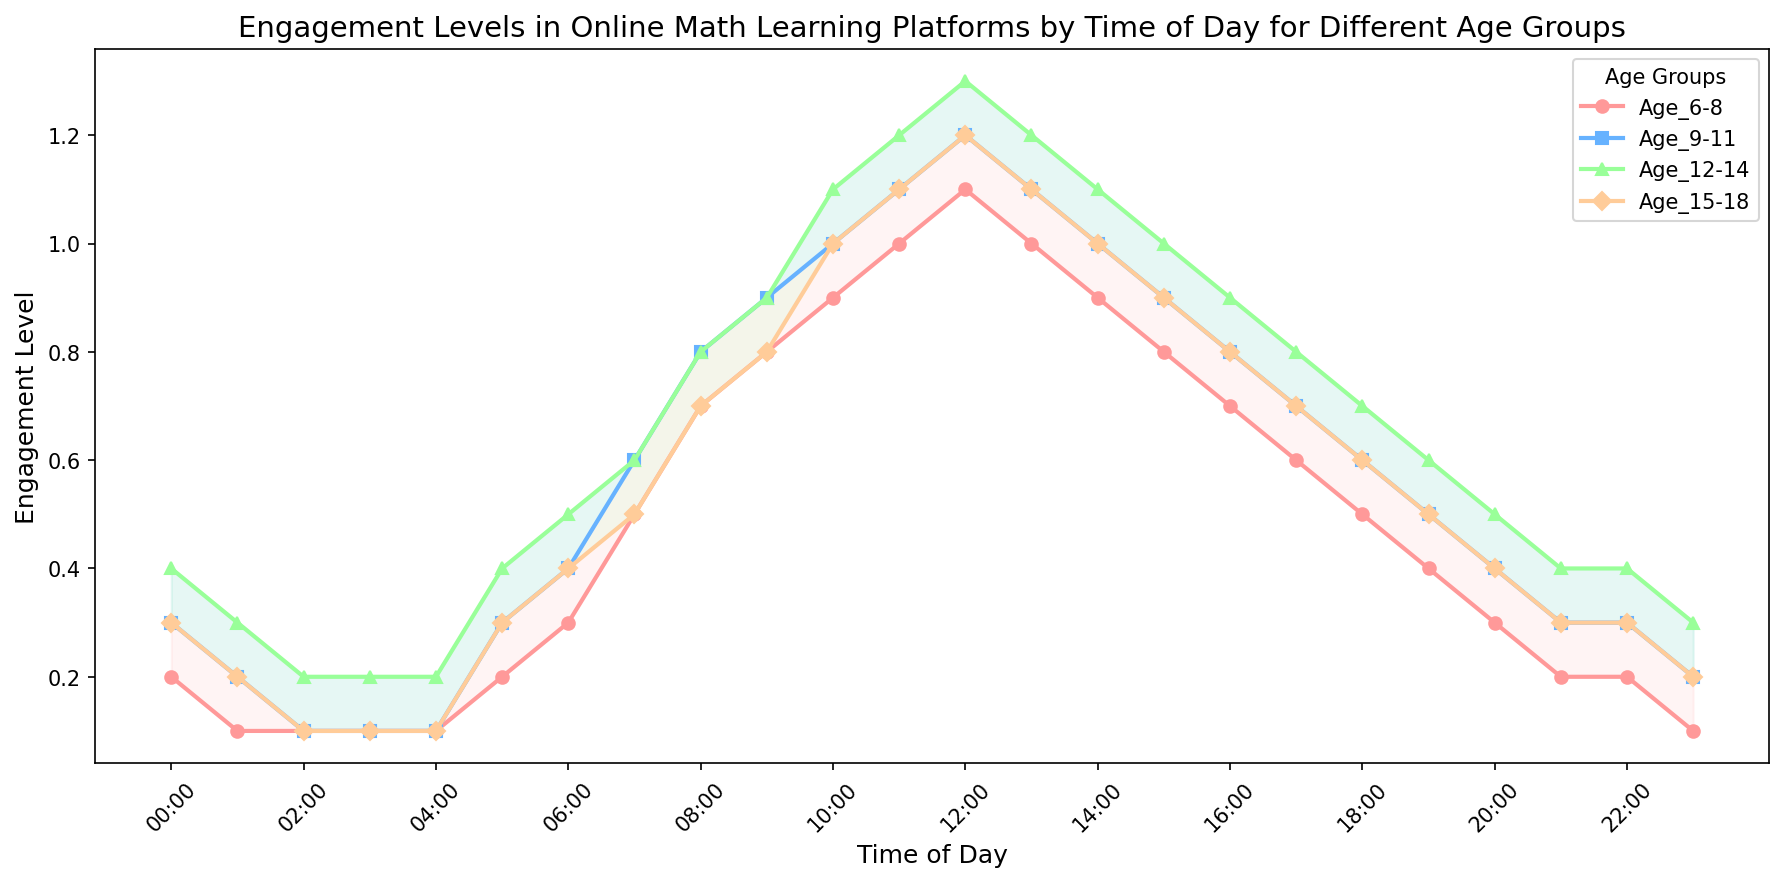What time of day shows the highest engagement level for the age group 12-14? The highest engagement level for age group 12-14 occurs at 12:00, where the engagement level is at 1.3.
Answer: 12:00 During which time period do all age groups show a rising trend in engagement levels? All age groups show a rising trend in engagement levels from 05:00 to 12:00, where engagement levels consistently increase.
Answer: 05:00 to 12:00 What is the difference in engagement level between age group 6-8 and age group 15-18 at 11:00? At 11:00, the engagement level for age group 6-8 is 1.0 while it is 1.1 for age group 15-18. The difference is 1.1 - 1.0 = 0.1.
Answer: 0.1 During what time period is the engagement difference between the age groups 6-8 and 9-11 the smallest? The engagement difference between age groups 6-8 and 9-11 is the smallest from 03:00 to 06:00 and from 21:00 to 22:00, where both age groups have the same engagement levels of 0.1 and 0.2.
Answer: 03:00 to 06:00 and 21:00 to 22:00 At what time does the age group 9-11 reach its peak engagement level and what is that level? The age group 9-11 reaches its peak engagement level at 12:00 with an engagement level of 1.2.
Answer: 12:00, 1.2 What is the average engagement level for age group 15-18 between 08:00 and 16:00? From 08:00 to 16:00, the engagement levels for age group 15-18 are 0.7, 0.8, 0.9, 1.0, 1.1, 1.2, 1.1, 1.0, and 0.9. The average is (0.7+0.8+0.9+1.0+1.1+1.2+1.1+1.0+0.9)/9 = 8.7/9 = 0.967.
Answer: 0.967 Which age group shows the earliest peak in engagement during the day? The earliest peak in engagement during the day occurs at 10:00 for age group 12-14 with an engagement level of 1.1.
Answer: Age group 12-14 